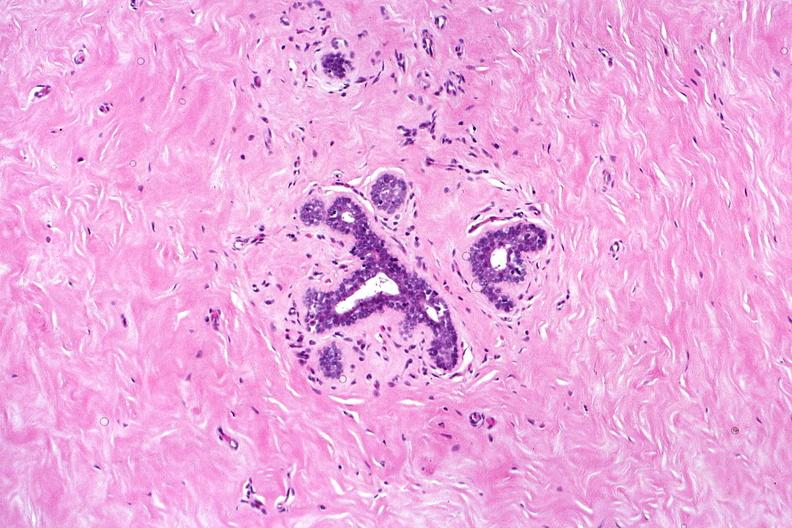does anencephaly show normal breast?
Answer the question using a single word or phrase. No 